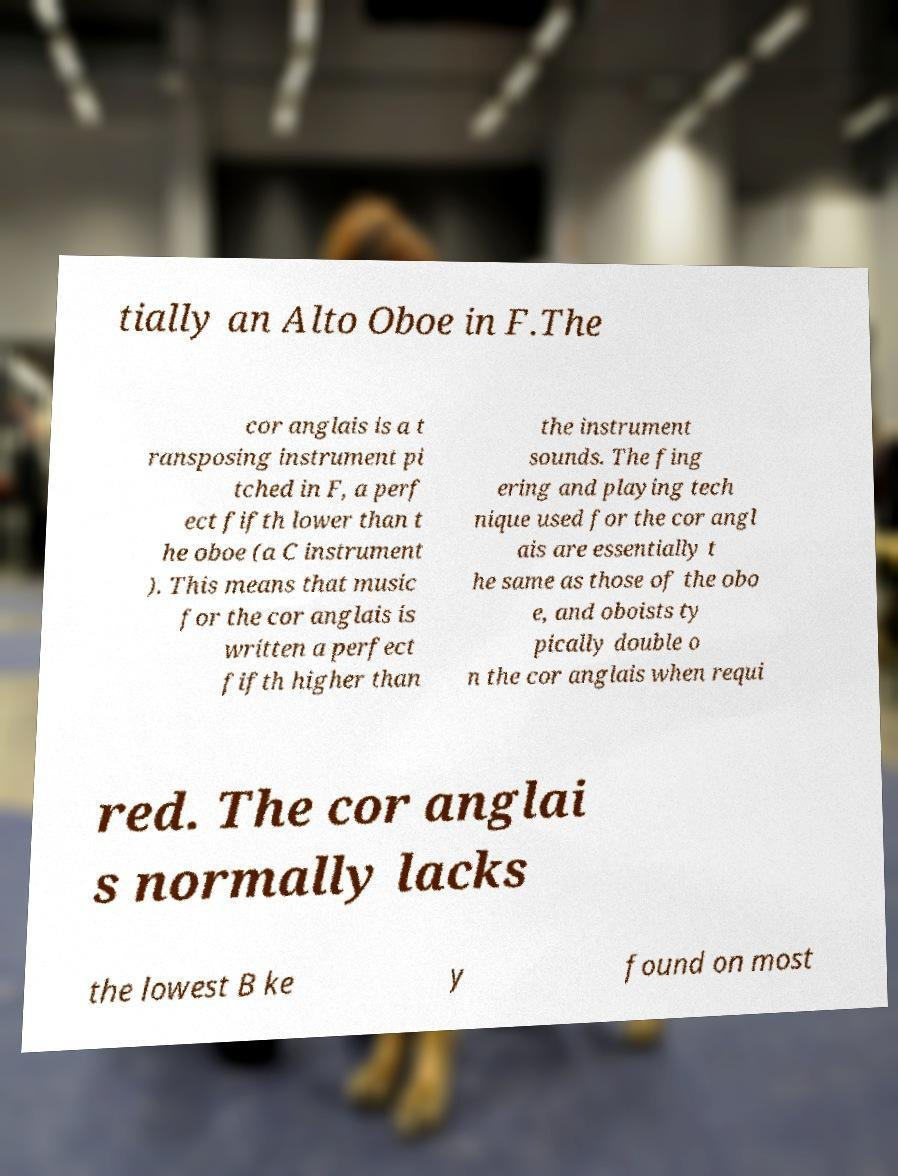Can you accurately transcribe the text from the provided image for me? tially an Alto Oboe in F.The cor anglais is a t ransposing instrument pi tched in F, a perf ect fifth lower than t he oboe (a C instrument ). This means that music for the cor anglais is written a perfect fifth higher than the instrument sounds. The fing ering and playing tech nique used for the cor angl ais are essentially t he same as those of the obo e, and oboists ty pically double o n the cor anglais when requi red. The cor anglai s normally lacks the lowest B ke y found on most 